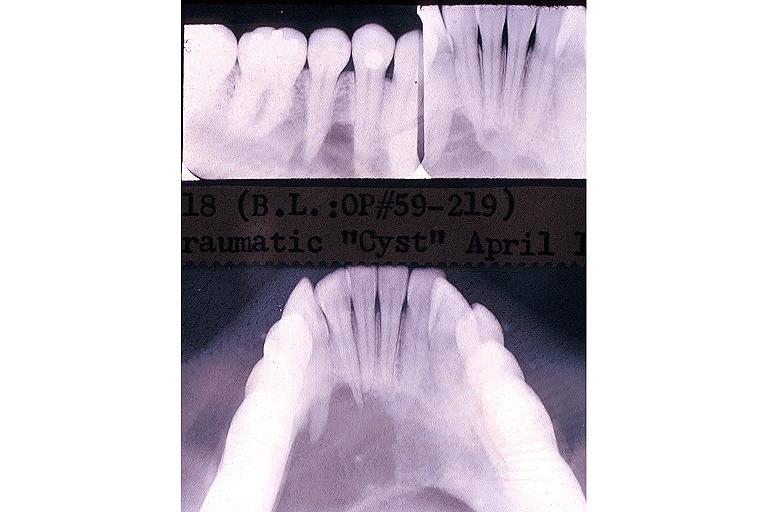s oral present?
Answer the question using a single word or phrase. Yes 